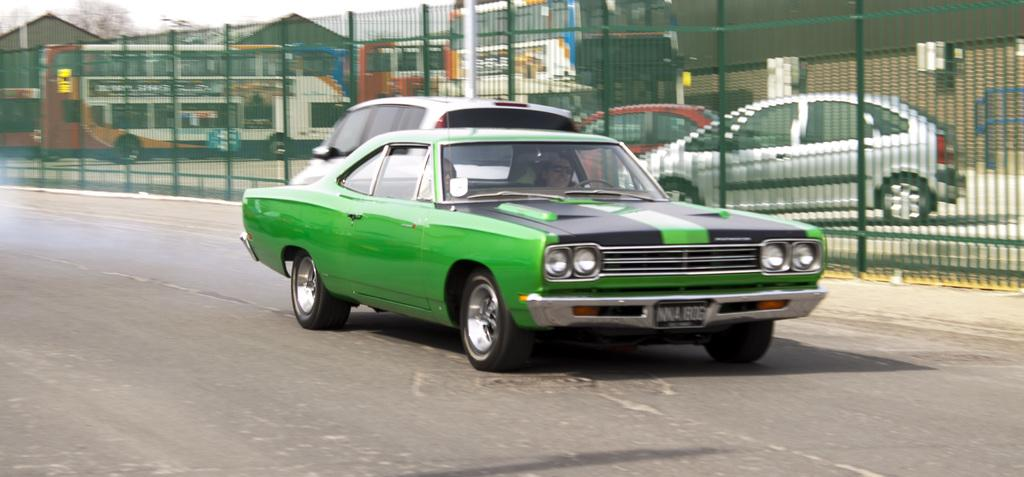What type of transportation can be seen on the road in the image? There are cars on the road in the image. What structure is present in the image? There is a fence in the image. What can be seen through the fence? Vehicles are visible through the fence. What is visible in the background of the image? There is a sky visible in the background of the image. How many eyes can be seen on the cars in the image? Cars do not have eyes, so this question cannot be answered based on the image. What type of yoke is being used by the vehicles in the image? There is no yoke present in the image; the vehicles are on a road and not being pulled by animals. 